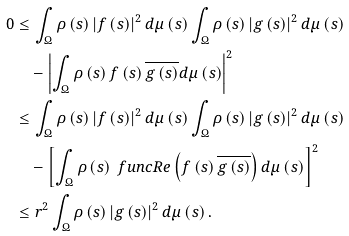<formula> <loc_0><loc_0><loc_500><loc_500>0 & \leq \int _ { \Omega } \rho \left ( s \right ) \left | f \left ( s \right ) \right | ^ { 2 } d \mu \left ( s \right ) \int _ { \Omega } \rho \left ( s \right ) \left | g \left ( s \right ) \right | ^ { 2 } d \mu \left ( s \right ) \\ & \quad - \left | \int _ { \Omega } \rho \left ( s \right ) f \left ( s \right ) \overline { g \left ( s \right ) } d \mu \left ( s \right ) \right | ^ { 2 } \\ & \leq \int _ { \Omega } \rho \left ( s \right ) \left | f \left ( s \right ) \right | ^ { 2 } d \mu \left ( s \right ) \int _ { \Omega } \rho \left ( s \right ) \left | g \left ( s \right ) \right | ^ { 2 } d \mu \left ( s \right ) \\ & \quad - \left [ \int _ { \Omega } \rho \left ( s \right ) \ f u n c { R e } \left ( f \left ( s \right ) \overline { g \left ( s \right ) } \right ) d \mu \left ( s \right ) \right ] ^ { 2 } \\ & \leq r ^ { 2 } \int _ { \Omega } \rho \left ( s \right ) \left | g \left ( s \right ) \right | ^ { 2 } d \mu \left ( s \right ) .</formula> 